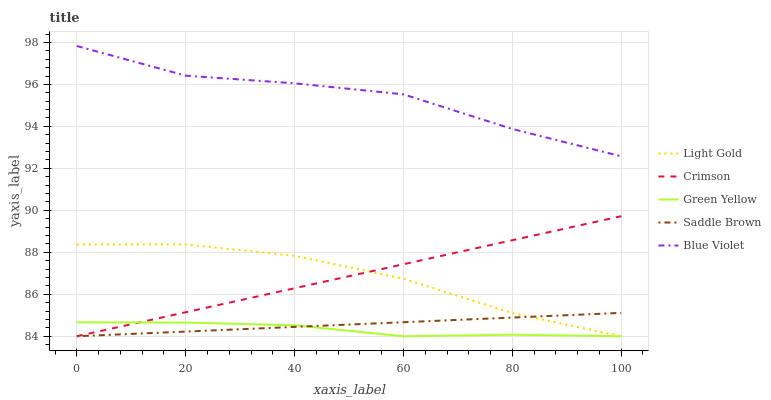Does Green Yellow have the minimum area under the curve?
Answer yes or no. Yes. Does Blue Violet have the maximum area under the curve?
Answer yes or no. Yes. Does Light Gold have the minimum area under the curve?
Answer yes or no. No. Does Light Gold have the maximum area under the curve?
Answer yes or no. No. Is Saddle Brown the smoothest?
Answer yes or no. Yes. Is Blue Violet the roughest?
Answer yes or no. Yes. Is Green Yellow the smoothest?
Answer yes or no. No. Is Green Yellow the roughest?
Answer yes or no. No. Does Crimson have the lowest value?
Answer yes or no. Yes. Does Blue Violet have the lowest value?
Answer yes or no. No. Does Blue Violet have the highest value?
Answer yes or no. Yes. Does Light Gold have the highest value?
Answer yes or no. No. Is Light Gold less than Blue Violet?
Answer yes or no. Yes. Is Blue Violet greater than Saddle Brown?
Answer yes or no. Yes. Does Saddle Brown intersect Crimson?
Answer yes or no. Yes. Is Saddle Brown less than Crimson?
Answer yes or no. No. Is Saddle Brown greater than Crimson?
Answer yes or no. No. Does Light Gold intersect Blue Violet?
Answer yes or no. No. 